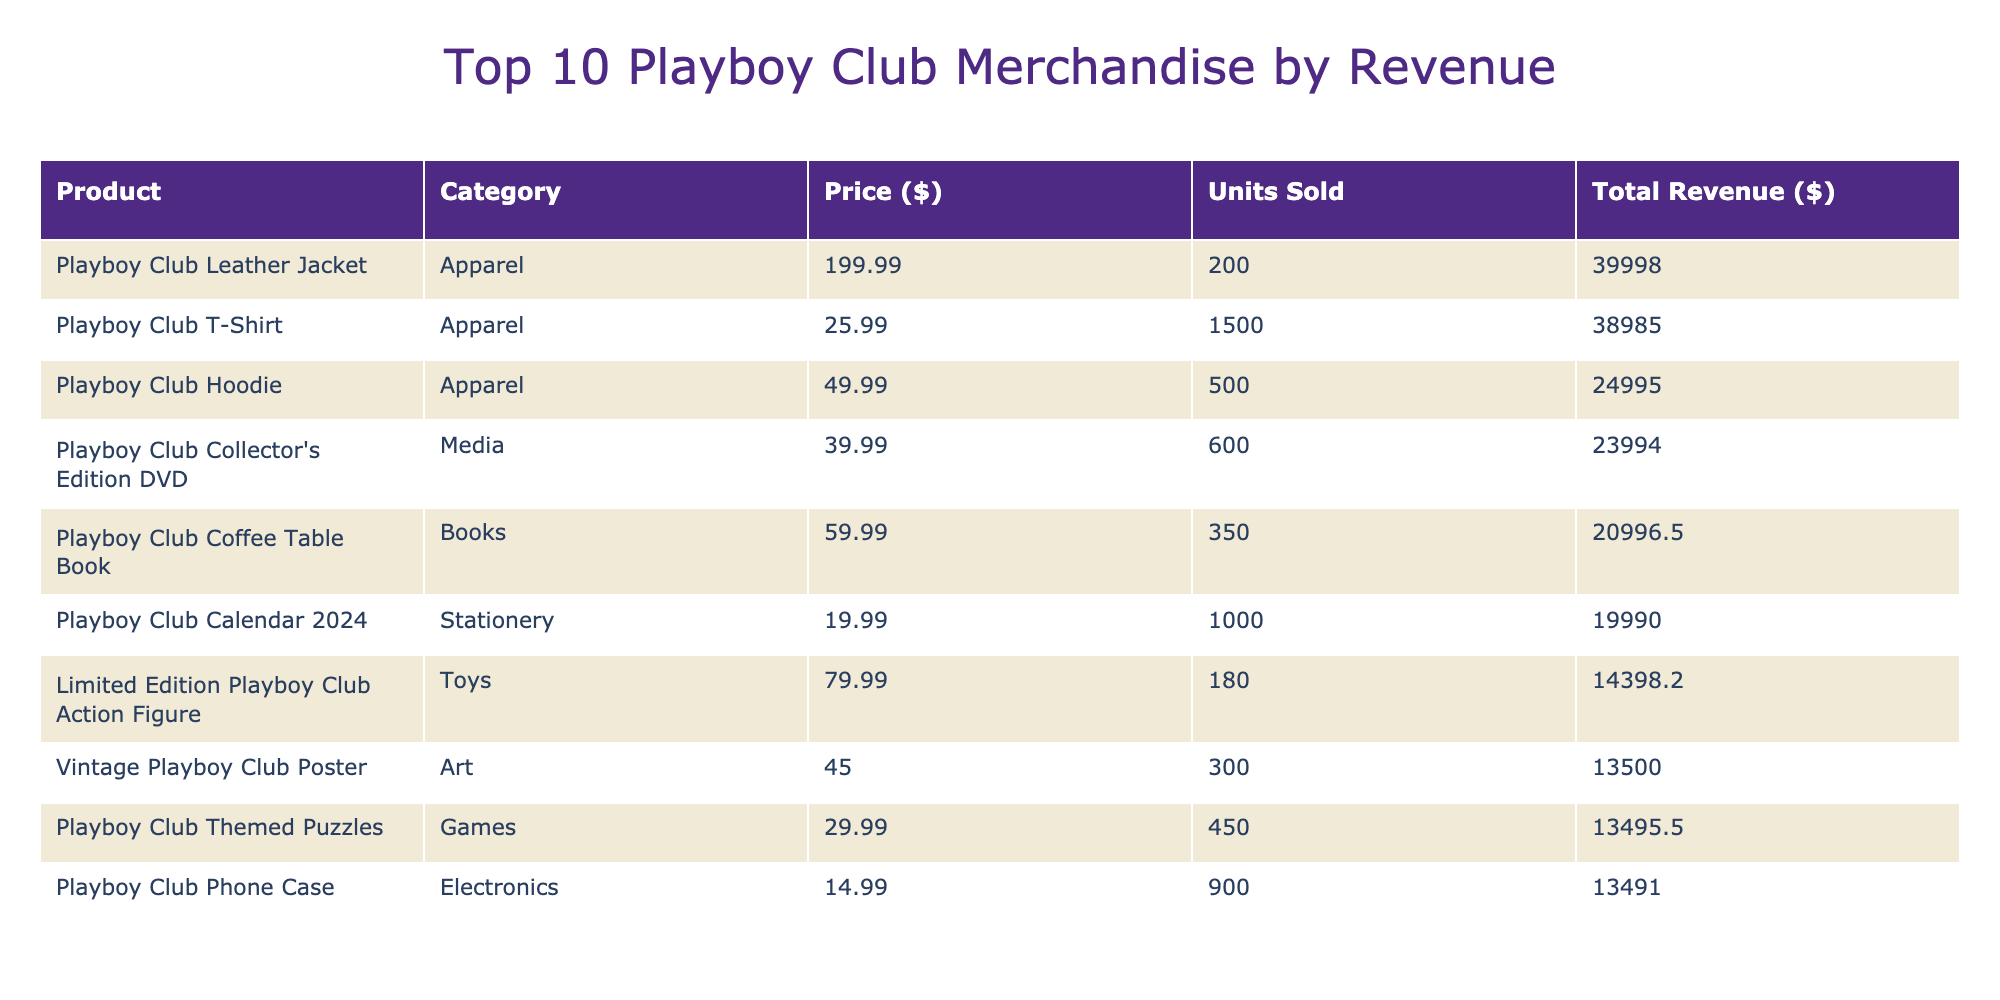What is the highest priced item in the table? The table shows the "Playboy Club Leather Jacket" with a price of $199.99, which is the highest among all listed items.
Answer: $199.99 How many units were sold for the Playboy Club Mug? In the table, the "Playboy Club Mug" is listed with 800 units sold.
Answer: 800 Which category did the Playboy Club Collector's Edition DVD belong to? The "Playboy Club Collector's Edition DVD" is categorized under "Media" based on the data in the table.
Answer: Media What is the total revenue generated by the Playboy Club Calendar 2024? The "Playboy Club Calendar 2024" has a price of $19.99 and 1000 units sold, so the total revenue is calculated as 19.99 * 1000 = $19,990.
Answer: $19,990 Is the average rating of the top 5 products above 4.5? To find this, we sum the ratings of the top 5 products: (4.9 + 4.8 + 4.7 + 4.6 + 4.5) = 24.5. Dividing by 5 gives an average of 24.5 / 5 = 4.9, which is indeed above 4.5.
Answer: Yes What item generated the lowest total revenue among the top 10? In the top 10, the "Playboy Club Themed Board Game" with 250 units sold and a price of $35.00 has a total revenue of 250 * 35 = $8,750, making it the lowest.
Answer: Playboy Club Themed Board Game How many products have a rating of 4.6 or higher? The table lists six products with ratings of 4.6 or higher: Playboy Club Mug, Playboy Club Wine Glass, Playboy Club Leather Jacket, Playboy Club Coffee Table Book, Playboy Club Calendar 2024, and Playboy Club Pin Set.
Answer: 6 What is the total revenue of all the apparel items combined? The apparel items are "Playboy Club T-Shirt" ($25.99 * 1500 = $38,985), "Playboy Club Hoodie" ($49.99 * 500 = $24,995), and "Playboy Club Leather Jacket" ($199.99 * 200 = $39,998). The total revenue is $38,985 + $24,995 + $39,998 = $103,978.
Answer: $103,978 Which sales channel had the most units sold for the Playboy Club Travel Flask? The "Playboy Club Travel Flask" was sold through the Online channel and had 650 units sold.
Answer: Online If we only consider the media category, what is the total revenue? The only item in the media category is the "Playboy Club Collector's Edition DVD" with a total revenue of 39.99 * 600 = $23,994.
Answer: $23,994 